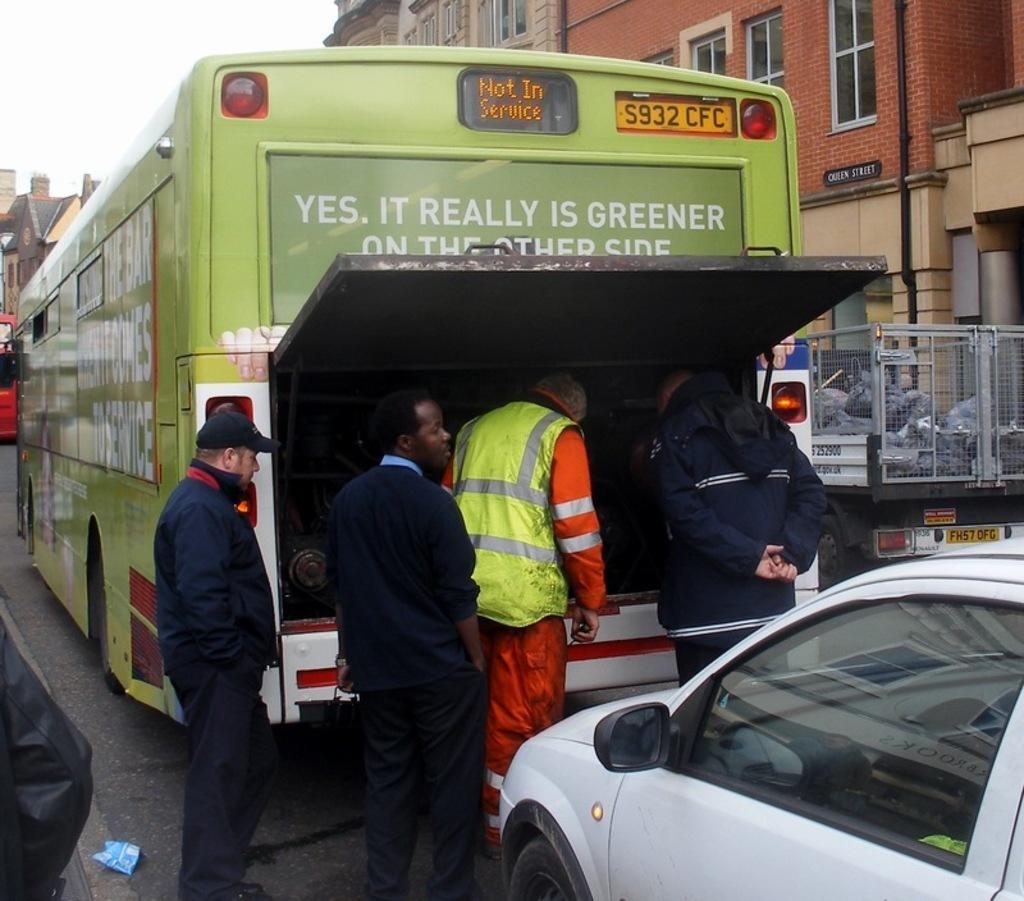Provide a one-sentence caption for the provided image. Several men look in the engine on the back of a bus that says Yes it is really greener on the other side. 